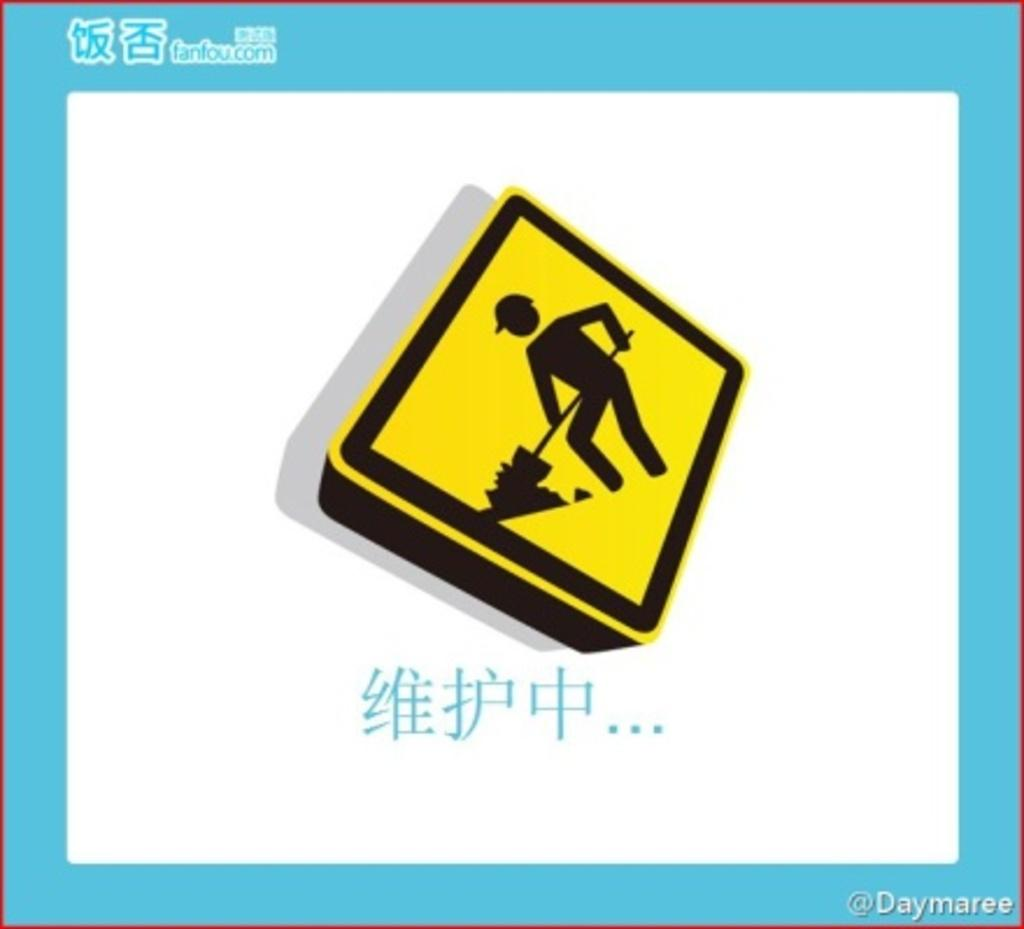<image>
Provide a brief description of the given image. A painting of a construction sign is surround by blue matting that says fanfou.com on it. 